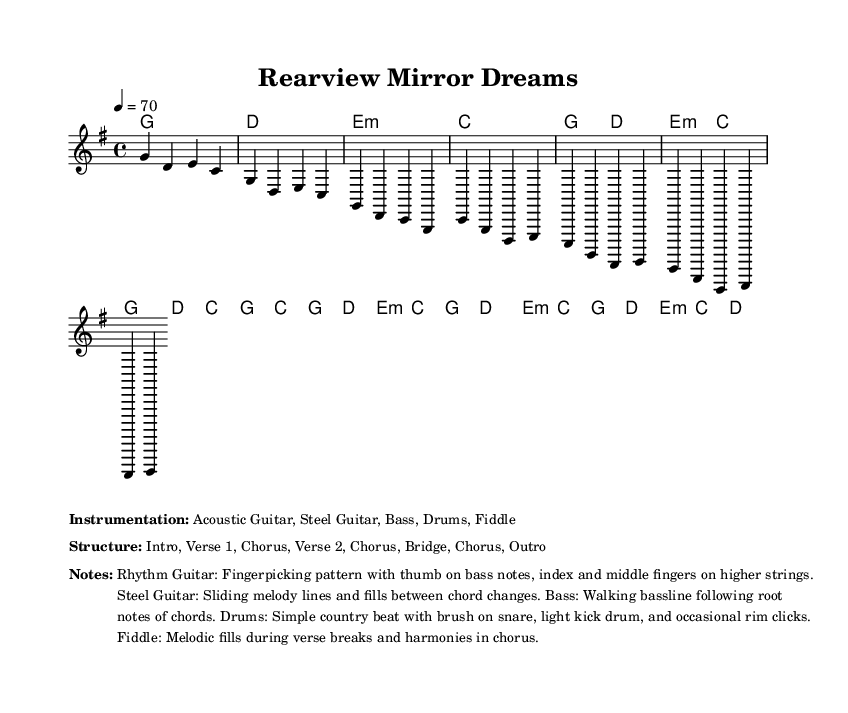What is the key signature of this music? The key signature is G major, which contains one sharp (F#). This can be identified from the initial section of the sheet music where the key is indicated.
Answer: G major What is the time signature of this music? The time signature is 4/4, meaning there are four beats in each measure. This is reflected in the notational elements of the sheet music where the "4/4" is clearly indicated.
Answer: 4/4 What is the tempo marking for this music? The tempo marking is 70 beats per minute, shown in the score where it states "4 = 70". This indicates the speed at which the piece should be played.
Answer: 70 How many sections are in the structure of the song? The structure of the song consists of 7 sections: Intro, Verse 1, Chorus, Verse 2, Chorus, Bridge, and Outro. This is detailed in the markup section outlining the overall structure of the piece.
Answer: 7 What kind of instrumentation is used in this music? The instrumentation includes Acoustic Guitar, Steel Guitar, Bass, Drums, and Fiddle. This information is provided in the markup notation section that lists the instruments.
Answer: Acoustic Guitar, Steel Guitar, Bass, Drums, Fiddle What is the main theme of the song as suggested by the title? The title "Rearview Mirror Dreams" suggests a theme of reflection and nostalgia, often associated with looking back on small-town life. This is inferred from the title's imagery conveying reminiscence.
Answer: Nostalgia What type of chord is used in the intro of the song? The intro uses major and minor chords: G, D, E minor, and C. This can be determined from the initial chord progression shown in the harmonies section.
Answer: G, D, E minor, C 